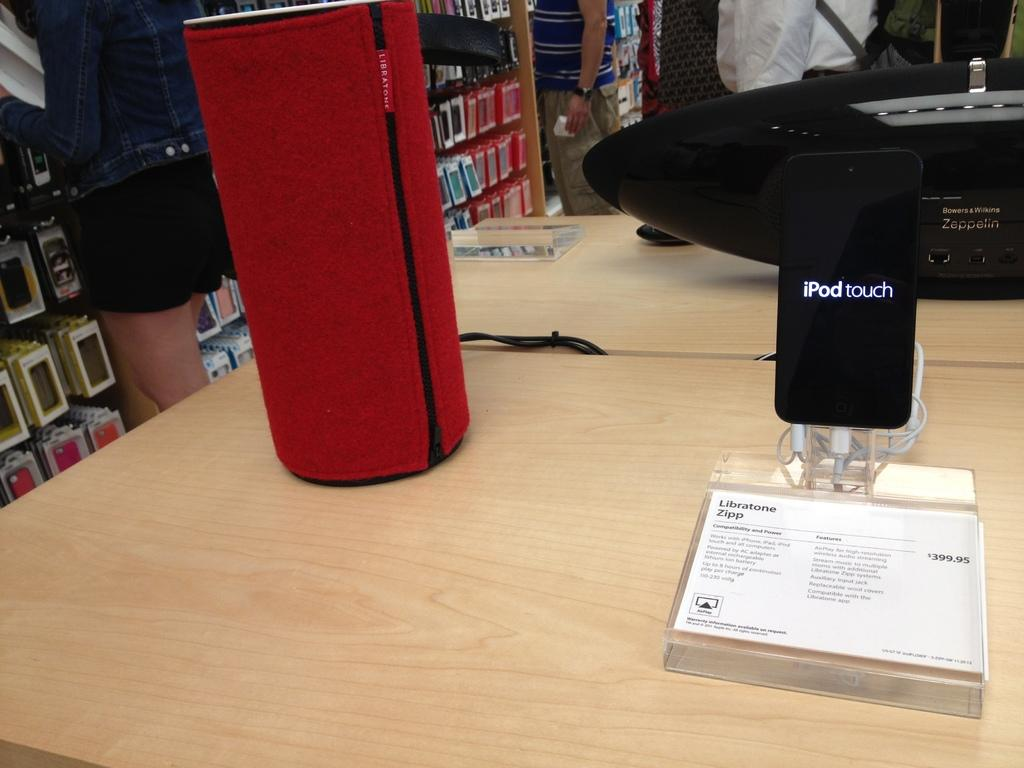What objects can be seen in the foreground of the picture? In the foreground of the picture, there are tables, speakers, a phone, cables, and paper. What items are on the left side of the picture? On the left side of the picture, there are mobile covers and a person standing. Can you describe the people in the background of the picture? There are people in the background of the picture, but their specific actions or characteristics are not mentioned in the provided facts. What type of wood is used to make the park benches in the image? There is no park or benches present in the image, so it is not possible to determine the type of wood used. 